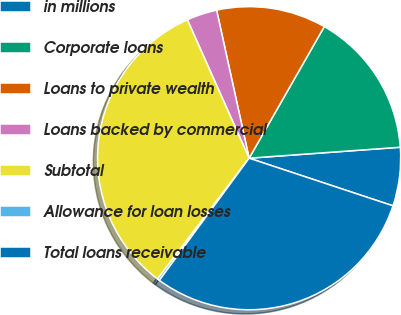<chart> <loc_0><loc_0><loc_500><loc_500><pie_chart><fcel>in millions<fcel>Corporate loans<fcel>Loans to private wealth<fcel>Loans backed by commercial<fcel>Subtotal<fcel>Allowance for loan losses<fcel>Total loans receivable<nl><fcel>6.24%<fcel>15.59%<fcel>11.7%<fcel>3.24%<fcel>33.0%<fcel>0.24%<fcel>30.0%<nl></chart> 